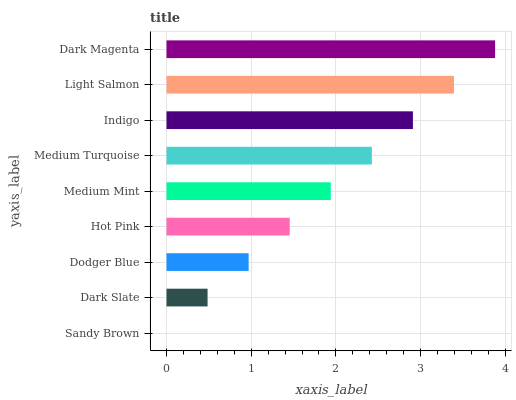Is Sandy Brown the minimum?
Answer yes or no. Yes. Is Dark Magenta the maximum?
Answer yes or no. Yes. Is Dark Slate the minimum?
Answer yes or no. No. Is Dark Slate the maximum?
Answer yes or no. No. Is Dark Slate greater than Sandy Brown?
Answer yes or no. Yes. Is Sandy Brown less than Dark Slate?
Answer yes or no. Yes. Is Sandy Brown greater than Dark Slate?
Answer yes or no. No. Is Dark Slate less than Sandy Brown?
Answer yes or no. No. Is Medium Mint the high median?
Answer yes or no. Yes. Is Medium Mint the low median?
Answer yes or no. Yes. Is Indigo the high median?
Answer yes or no. No. Is Dodger Blue the low median?
Answer yes or no. No. 